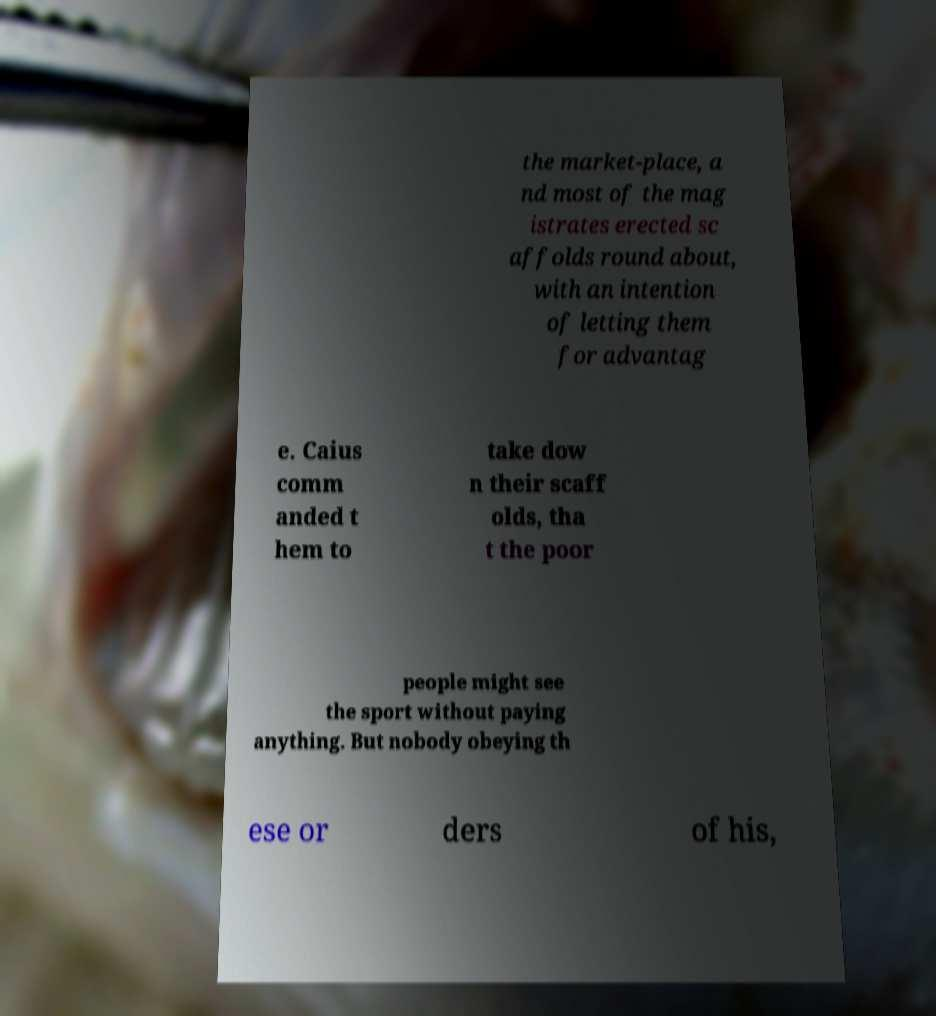I need the written content from this picture converted into text. Can you do that? the market-place, a nd most of the mag istrates erected sc affolds round about, with an intention of letting them for advantag e. Caius comm anded t hem to take dow n their scaff olds, tha t the poor people might see the sport without paying anything. But nobody obeying th ese or ders of his, 